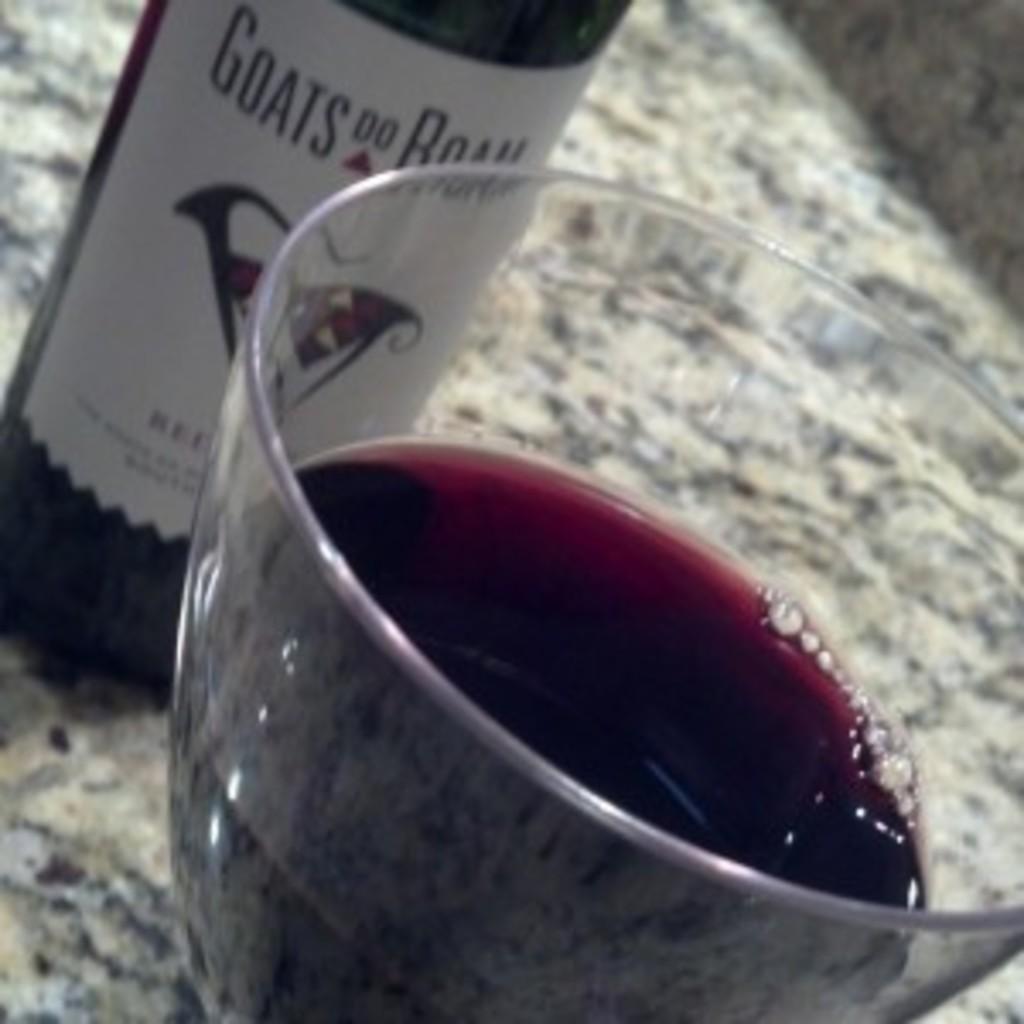What is the brand of this wine?
Keep it short and to the point. Goats do roam. 